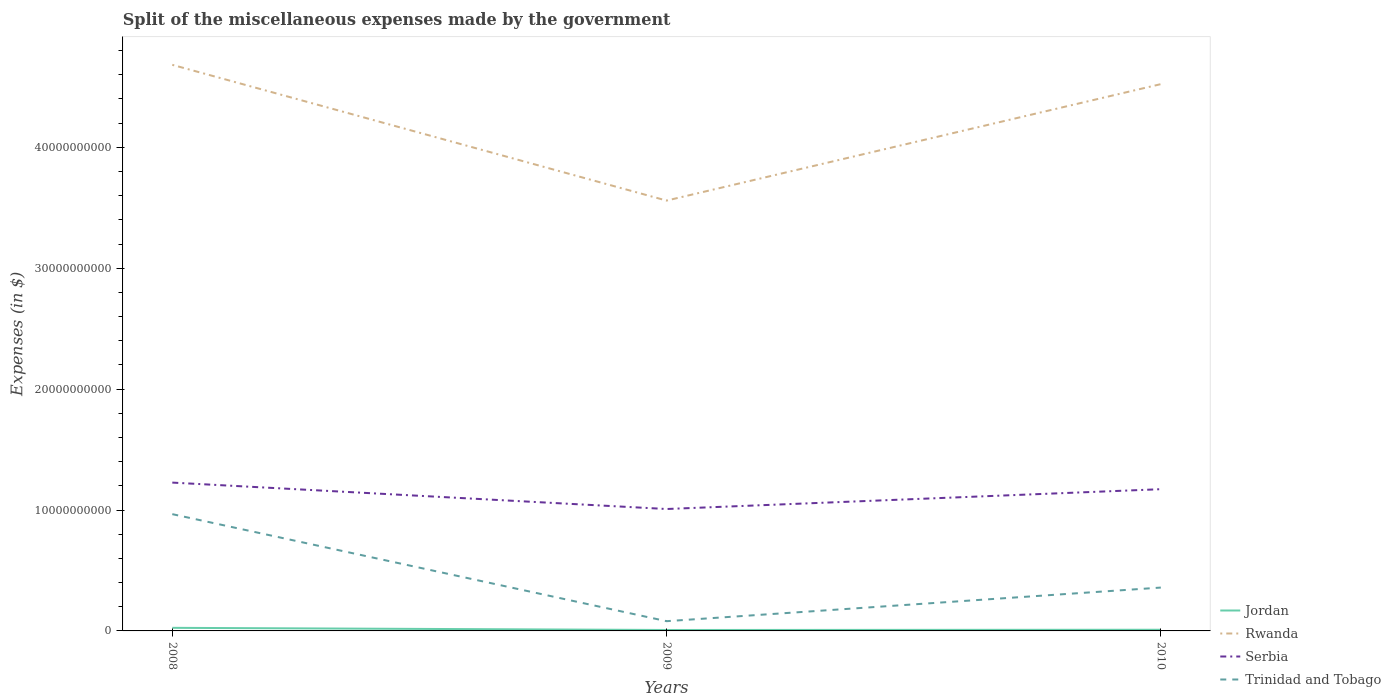Across all years, what is the maximum miscellaneous expenses made by the government in Rwanda?
Your answer should be very brief. 3.56e+1. What is the total miscellaneous expenses made by the government in Jordan in the graph?
Provide a succinct answer. -1.91e+07. What is the difference between the highest and the second highest miscellaneous expenses made by the government in Jordan?
Keep it short and to the point. 1.78e+08. What is the difference between the highest and the lowest miscellaneous expenses made by the government in Jordan?
Give a very brief answer. 1. Is the miscellaneous expenses made by the government in Rwanda strictly greater than the miscellaneous expenses made by the government in Serbia over the years?
Keep it short and to the point. No. How many lines are there?
Make the answer very short. 4. How many years are there in the graph?
Provide a short and direct response. 3. What is the difference between two consecutive major ticks on the Y-axis?
Your answer should be very brief. 1.00e+1. Does the graph contain any zero values?
Make the answer very short. No. Does the graph contain grids?
Ensure brevity in your answer.  No. Where does the legend appear in the graph?
Your answer should be very brief. Bottom right. How are the legend labels stacked?
Keep it short and to the point. Vertical. What is the title of the graph?
Give a very brief answer. Split of the miscellaneous expenses made by the government. What is the label or title of the Y-axis?
Give a very brief answer. Expenses (in $). What is the Expenses (in $) in Jordan in 2008?
Ensure brevity in your answer.  2.55e+08. What is the Expenses (in $) of Rwanda in 2008?
Provide a succinct answer. 4.68e+1. What is the Expenses (in $) in Serbia in 2008?
Offer a terse response. 1.23e+1. What is the Expenses (in $) of Trinidad and Tobago in 2008?
Provide a short and direct response. 9.66e+09. What is the Expenses (in $) of Jordan in 2009?
Your answer should be very brief. 7.76e+07. What is the Expenses (in $) of Rwanda in 2009?
Offer a very short reply. 3.56e+1. What is the Expenses (in $) of Serbia in 2009?
Keep it short and to the point. 1.01e+1. What is the Expenses (in $) in Trinidad and Tobago in 2009?
Offer a very short reply. 8.06e+08. What is the Expenses (in $) of Jordan in 2010?
Offer a terse response. 9.67e+07. What is the Expenses (in $) in Rwanda in 2010?
Ensure brevity in your answer.  4.52e+1. What is the Expenses (in $) of Serbia in 2010?
Give a very brief answer. 1.17e+1. What is the Expenses (in $) in Trinidad and Tobago in 2010?
Ensure brevity in your answer.  3.59e+09. Across all years, what is the maximum Expenses (in $) of Jordan?
Ensure brevity in your answer.  2.55e+08. Across all years, what is the maximum Expenses (in $) in Rwanda?
Your response must be concise. 4.68e+1. Across all years, what is the maximum Expenses (in $) in Serbia?
Keep it short and to the point. 1.23e+1. Across all years, what is the maximum Expenses (in $) in Trinidad and Tobago?
Keep it short and to the point. 9.66e+09. Across all years, what is the minimum Expenses (in $) in Jordan?
Offer a very short reply. 7.76e+07. Across all years, what is the minimum Expenses (in $) of Rwanda?
Provide a succinct answer. 3.56e+1. Across all years, what is the minimum Expenses (in $) in Serbia?
Offer a terse response. 1.01e+1. Across all years, what is the minimum Expenses (in $) of Trinidad and Tobago?
Keep it short and to the point. 8.06e+08. What is the total Expenses (in $) of Jordan in the graph?
Your answer should be compact. 4.30e+08. What is the total Expenses (in $) of Rwanda in the graph?
Offer a very short reply. 1.28e+11. What is the total Expenses (in $) in Serbia in the graph?
Provide a short and direct response. 3.41e+1. What is the total Expenses (in $) in Trinidad and Tobago in the graph?
Provide a succinct answer. 1.41e+1. What is the difference between the Expenses (in $) in Jordan in 2008 and that in 2009?
Keep it short and to the point. 1.78e+08. What is the difference between the Expenses (in $) of Rwanda in 2008 and that in 2009?
Make the answer very short. 1.12e+1. What is the difference between the Expenses (in $) of Serbia in 2008 and that in 2009?
Offer a very short reply. 2.19e+09. What is the difference between the Expenses (in $) in Trinidad and Tobago in 2008 and that in 2009?
Make the answer very short. 8.85e+09. What is the difference between the Expenses (in $) of Jordan in 2008 and that in 2010?
Offer a terse response. 1.59e+08. What is the difference between the Expenses (in $) in Rwanda in 2008 and that in 2010?
Make the answer very short. 1.60e+09. What is the difference between the Expenses (in $) in Serbia in 2008 and that in 2010?
Provide a succinct answer. 5.46e+08. What is the difference between the Expenses (in $) of Trinidad and Tobago in 2008 and that in 2010?
Give a very brief answer. 6.07e+09. What is the difference between the Expenses (in $) in Jordan in 2009 and that in 2010?
Provide a succinct answer. -1.91e+07. What is the difference between the Expenses (in $) of Rwanda in 2009 and that in 2010?
Your response must be concise. -9.63e+09. What is the difference between the Expenses (in $) in Serbia in 2009 and that in 2010?
Your response must be concise. -1.64e+09. What is the difference between the Expenses (in $) of Trinidad and Tobago in 2009 and that in 2010?
Your answer should be very brief. -2.78e+09. What is the difference between the Expenses (in $) of Jordan in 2008 and the Expenses (in $) of Rwanda in 2009?
Make the answer very short. -3.53e+1. What is the difference between the Expenses (in $) in Jordan in 2008 and the Expenses (in $) in Serbia in 2009?
Provide a short and direct response. -9.83e+09. What is the difference between the Expenses (in $) in Jordan in 2008 and the Expenses (in $) in Trinidad and Tobago in 2009?
Give a very brief answer. -5.50e+08. What is the difference between the Expenses (in $) in Rwanda in 2008 and the Expenses (in $) in Serbia in 2009?
Your answer should be compact. 3.67e+1. What is the difference between the Expenses (in $) in Rwanda in 2008 and the Expenses (in $) in Trinidad and Tobago in 2009?
Your answer should be compact. 4.60e+1. What is the difference between the Expenses (in $) in Serbia in 2008 and the Expenses (in $) in Trinidad and Tobago in 2009?
Offer a very short reply. 1.15e+1. What is the difference between the Expenses (in $) in Jordan in 2008 and the Expenses (in $) in Rwanda in 2010?
Your answer should be compact. -4.50e+1. What is the difference between the Expenses (in $) of Jordan in 2008 and the Expenses (in $) of Serbia in 2010?
Provide a succinct answer. -1.15e+1. What is the difference between the Expenses (in $) in Jordan in 2008 and the Expenses (in $) in Trinidad and Tobago in 2010?
Provide a succinct answer. -3.33e+09. What is the difference between the Expenses (in $) in Rwanda in 2008 and the Expenses (in $) in Serbia in 2010?
Offer a very short reply. 3.51e+1. What is the difference between the Expenses (in $) of Rwanda in 2008 and the Expenses (in $) of Trinidad and Tobago in 2010?
Offer a very short reply. 4.32e+1. What is the difference between the Expenses (in $) of Serbia in 2008 and the Expenses (in $) of Trinidad and Tobago in 2010?
Your answer should be compact. 8.68e+09. What is the difference between the Expenses (in $) in Jordan in 2009 and the Expenses (in $) in Rwanda in 2010?
Provide a short and direct response. -4.51e+1. What is the difference between the Expenses (in $) in Jordan in 2009 and the Expenses (in $) in Serbia in 2010?
Provide a short and direct response. -1.16e+1. What is the difference between the Expenses (in $) of Jordan in 2009 and the Expenses (in $) of Trinidad and Tobago in 2010?
Your answer should be compact. -3.51e+09. What is the difference between the Expenses (in $) of Rwanda in 2009 and the Expenses (in $) of Serbia in 2010?
Your response must be concise. 2.39e+1. What is the difference between the Expenses (in $) in Rwanda in 2009 and the Expenses (in $) in Trinidad and Tobago in 2010?
Provide a short and direct response. 3.20e+1. What is the difference between the Expenses (in $) in Serbia in 2009 and the Expenses (in $) in Trinidad and Tobago in 2010?
Keep it short and to the point. 6.50e+09. What is the average Expenses (in $) of Jordan per year?
Keep it short and to the point. 1.43e+08. What is the average Expenses (in $) of Rwanda per year?
Your answer should be very brief. 4.25e+1. What is the average Expenses (in $) of Serbia per year?
Keep it short and to the point. 1.14e+1. What is the average Expenses (in $) in Trinidad and Tobago per year?
Offer a very short reply. 4.68e+09. In the year 2008, what is the difference between the Expenses (in $) in Jordan and Expenses (in $) in Rwanda?
Provide a succinct answer. -4.66e+1. In the year 2008, what is the difference between the Expenses (in $) in Jordan and Expenses (in $) in Serbia?
Your response must be concise. -1.20e+1. In the year 2008, what is the difference between the Expenses (in $) in Jordan and Expenses (in $) in Trinidad and Tobago?
Keep it short and to the point. -9.40e+09. In the year 2008, what is the difference between the Expenses (in $) in Rwanda and Expenses (in $) in Serbia?
Your answer should be very brief. 3.46e+1. In the year 2008, what is the difference between the Expenses (in $) of Rwanda and Expenses (in $) of Trinidad and Tobago?
Keep it short and to the point. 3.72e+1. In the year 2008, what is the difference between the Expenses (in $) of Serbia and Expenses (in $) of Trinidad and Tobago?
Provide a succinct answer. 2.61e+09. In the year 2009, what is the difference between the Expenses (in $) in Jordan and Expenses (in $) in Rwanda?
Your response must be concise. -3.55e+1. In the year 2009, what is the difference between the Expenses (in $) of Jordan and Expenses (in $) of Serbia?
Offer a very short reply. -1.00e+1. In the year 2009, what is the difference between the Expenses (in $) of Jordan and Expenses (in $) of Trinidad and Tobago?
Provide a short and direct response. -7.28e+08. In the year 2009, what is the difference between the Expenses (in $) of Rwanda and Expenses (in $) of Serbia?
Provide a short and direct response. 2.55e+1. In the year 2009, what is the difference between the Expenses (in $) of Rwanda and Expenses (in $) of Trinidad and Tobago?
Keep it short and to the point. 3.48e+1. In the year 2009, what is the difference between the Expenses (in $) in Serbia and Expenses (in $) in Trinidad and Tobago?
Offer a terse response. 9.28e+09. In the year 2010, what is the difference between the Expenses (in $) in Jordan and Expenses (in $) in Rwanda?
Your answer should be compact. -4.51e+1. In the year 2010, what is the difference between the Expenses (in $) of Jordan and Expenses (in $) of Serbia?
Offer a terse response. -1.16e+1. In the year 2010, what is the difference between the Expenses (in $) of Jordan and Expenses (in $) of Trinidad and Tobago?
Ensure brevity in your answer.  -3.49e+09. In the year 2010, what is the difference between the Expenses (in $) of Rwanda and Expenses (in $) of Serbia?
Ensure brevity in your answer.  3.35e+1. In the year 2010, what is the difference between the Expenses (in $) of Rwanda and Expenses (in $) of Trinidad and Tobago?
Keep it short and to the point. 4.16e+1. In the year 2010, what is the difference between the Expenses (in $) in Serbia and Expenses (in $) in Trinidad and Tobago?
Your response must be concise. 8.14e+09. What is the ratio of the Expenses (in $) in Jordan in 2008 to that in 2009?
Ensure brevity in your answer.  3.29. What is the ratio of the Expenses (in $) of Rwanda in 2008 to that in 2009?
Ensure brevity in your answer.  1.32. What is the ratio of the Expenses (in $) of Serbia in 2008 to that in 2009?
Make the answer very short. 1.22. What is the ratio of the Expenses (in $) in Trinidad and Tobago in 2008 to that in 2009?
Ensure brevity in your answer.  11.99. What is the ratio of the Expenses (in $) in Jordan in 2008 to that in 2010?
Your answer should be compact. 2.64. What is the ratio of the Expenses (in $) of Rwanda in 2008 to that in 2010?
Provide a short and direct response. 1.04. What is the ratio of the Expenses (in $) of Serbia in 2008 to that in 2010?
Offer a terse response. 1.05. What is the ratio of the Expenses (in $) in Trinidad and Tobago in 2008 to that in 2010?
Make the answer very short. 2.69. What is the ratio of the Expenses (in $) of Jordan in 2009 to that in 2010?
Ensure brevity in your answer.  0.8. What is the ratio of the Expenses (in $) of Rwanda in 2009 to that in 2010?
Provide a succinct answer. 0.79. What is the ratio of the Expenses (in $) of Serbia in 2009 to that in 2010?
Give a very brief answer. 0.86. What is the ratio of the Expenses (in $) of Trinidad and Tobago in 2009 to that in 2010?
Keep it short and to the point. 0.22. What is the difference between the highest and the second highest Expenses (in $) in Jordan?
Provide a succinct answer. 1.59e+08. What is the difference between the highest and the second highest Expenses (in $) in Rwanda?
Ensure brevity in your answer.  1.60e+09. What is the difference between the highest and the second highest Expenses (in $) in Serbia?
Ensure brevity in your answer.  5.46e+08. What is the difference between the highest and the second highest Expenses (in $) of Trinidad and Tobago?
Offer a very short reply. 6.07e+09. What is the difference between the highest and the lowest Expenses (in $) in Jordan?
Your response must be concise. 1.78e+08. What is the difference between the highest and the lowest Expenses (in $) of Rwanda?
Ensure brevity in your answer.  1.12e+1. What is the difference between the highest and the lowest Expenses (in $) in Serbia?
Make the answer very short. 2.19e+09. What is the difference between the highest and the lowest Expenses (in $) in Trinidad and Tobago?
Make the answer very short. 8.85e+09. 